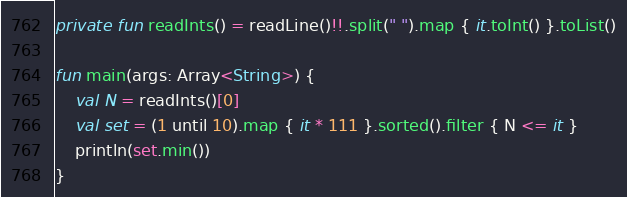<code> <loc_0><loc_0><loc_500><loc_500><_Kotlin_>private fun readInts() = readLine()!!.split(" ").map { it.toInt() }.toList()

fun main(args: Array<String>) {
    val N = readInts()[0]
    val set = (1 until 10).map { it * 111 }.sorted().filter { N <= it }
    println(set.min())
}</code> 